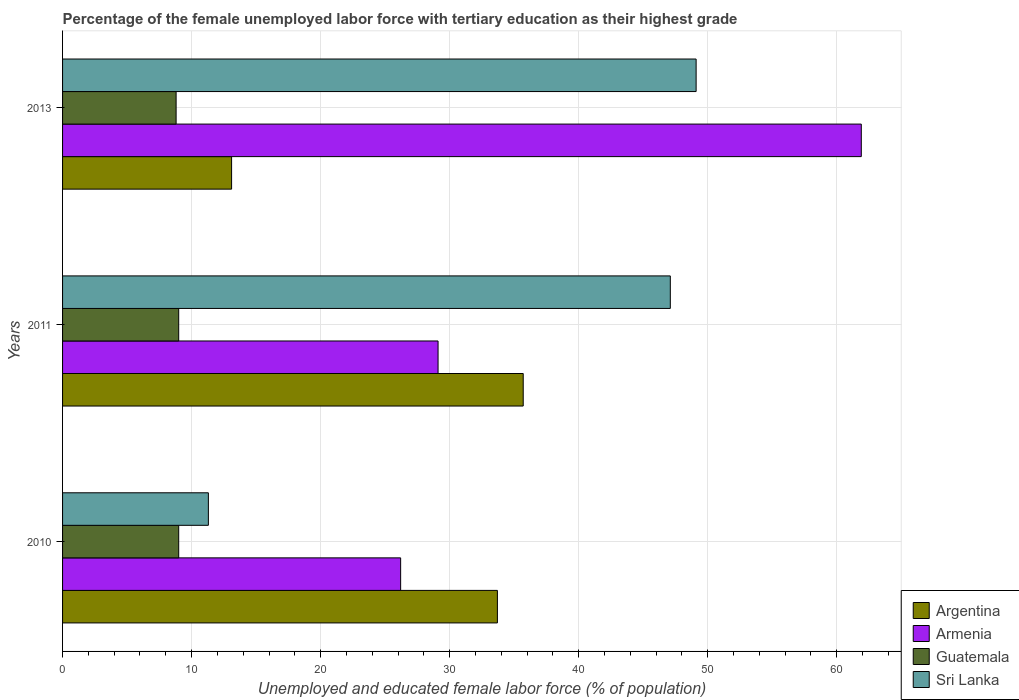How many different coloured bars are there?
Your answer should be very brief. 4. How many groups of bars are there?
Provide a short and direct response. 3. Are the number of bars per tick equal to the number of legend labels?
Ensure brevity in your answer.  Yes. Are the number of bars on each tick of the Y-axis equal?
Provide a succinct answer. Yes. What is the label of the 2nd group of bars from the top?
Give a very brief answer. 2011. What is the percentage of the unemployed female labor force with tertiary education in Guatemala in 2011?
Your answer should be compact. 9. Across all years, what is the maximum percentage of the unemployed female labor force with tertiary education in Sri Lanka?
Your response must be concise. 49.1. Across all years, what is the minimum percentage of the unemployed female labor force with tertiary education in Sri Lanka?
Make the answer very short. 11.3. In which year was the percentage of the unemployed female labor force with tertiary education in Argentina maximum?
Keep it short and to the point. 2011. What is the total percentage of the unemployed female labor force with tertiary education in Argentina in the graph?
Keep it short and to the point. 82.5. What is the difference between the percentage of the unemployed female labor force with tertiary education in Sri Lanka in 2010 and that in 2013?
Your answer should be very brief. -37.8. What is the difference between the percentage of the unemployed female labor force with tertiary education in Guatemala in 2010 and the percentage of the unemployed female labor force with tertiary education in Argentina in 2013?
Keep it short and to the point. -4.1. What is the average percentage of the unemployed female labor force with tertiary education in Armenia per year?
Your answer should be compact. 39.07. In the year 2011, what is the difference between the percentage of the unemployed female labor force with tertiary education in Guatemala and percentage of the unemployed female labor force with tertiary education in Armenia?
Keep it short and to the point. -20.1. In how many years, is the percentage of the unemployed female labor force with tertiary education in Argentina greater than 6 %?
Make the answer very short. 3. Is the percentage of the unemployed female labor force with tertiary education in Sri Lanka in 2010 less than that in 2013?
Provide a short and direct response. Yes. Is the difference between the percentage of the unemployed female labor force with tertiary education in Guatemala in 2010 and 2011 greater than the difference between the percentage of the unemployed female labor force with tertiary education in Armenia in 2010 and 2011?
Your response must be concise. Yes. What is the difference between the highest and the second highest percentage of the unemployed female labor force with tertiary education in Argentina?
Provide a short and direct response. 2. What is the difference between the highest and the lowest percentage of the unemployed female labor force with tertiary education in Guatemala?
Give a very brief answer. 0.2. What does the 3rd bar from the top in 2013 represents?
Your answer should be compact. Armenia. What does the 3rd bar from the bottom in 2011 represents?
Offer a terse response. Guatemala. How many bars are there?
Provide a succinct answer. 12. Does the graph contain grids?
Make the answer very short. Yes. How many legend labels are there?
Offer a very short reply. 4. What is the title of the graph?
Keep it short and to the point. Percentage of the female unemployed labor force with tertiary education as their highest grade. What is the label or title of the X-axis?
Offer a very short reply. Unemployed and educated female labor force (% of population). What is the Unemployed and educated female labor force (% of population) of Argentina in 2010?
Provide a short and direct response. 33.7. What is the Unemployed and educated female labor force (% of population) in Armenia in 2010?
Offer a terse response. 26.2. What is the Unemployed and educated female labor force (% of population) in Guatemala in 2010?
Your response must be concise. 9. What is the Unemployed and educated female labor force (% of population) in Sri Lanka in 2010?
Keep it short and to the point. 11.3. What is the Unemployed and educated female labor force (% of population) in Argentina in 2011?
Offer a terse response. 35.7. What is the Unemployed and educated female labor force (% of population) of Armenia in 2011?
Offer a very short reply. 29.1. What is the Unemployed and educated female labor force (% of population) in Guatemala in 2011?
Give a very brief answer. 9. What is the Unemployed and educated female labor force (% of population) in Sri Lanka in 2011?
Ensure brevity in your answer.  47.1. What is the Unemployed and educated female labor force (% of population) in Argentina in 2013?
Offer a very short reply. 13.1. What is the Unemployed and educated female labor force (% of population) of Armenia in 2013?
Keep it short and to the point. 61.9. What is the Unemployed and educated female labor force (% of population) of Guatemala in 2013?
Provide a succinct answer. 8.8. What is the Unemployed and educated female labor force (% of population) of Sri Lanka in 2013?
Give a very brief answer. 49.1. Across all years, what is the maximum Unemployed and educated female labor force (% of population) in Argentina?
Make the answer very short. 35.7. Across all years, what is the maximum Unemployed and educated female labor force (% of population) in Armenia?
Offer a very short reply. 61.9. Across all years, what is the maximum Unemployed and educated female labor force (% of population) in Guatemala?
Provide a succinct answer. 9. Across all years, what is the maximum Unemployed and educated female labor force (% of population) of Sri Lanka?
Your response must be concise. 49.1. Across all years, what is the minimum Unemployed and educated female labor force (% of population) in Argentina?
Provide a succinct answer. 13.1. Across all years, what is the minimum Unemployed and educated female labor force (% of population) of Armenia?
Give a very brief answer. 26.2. Across all years, what is the minimum Unemployed and educated female labor force (% of population) in Guatemala?
Provide a short and direct response. 8.8. Across all years, what is the minimum Unemployed and educated female labor force (% of population) in Sri Lanka?
Your response must be concise. 11.3. What is the total Unemployed and educated female labor force (% of population) of Argentina in the graph?
Offer a terse response. 82.5. What is the total Unemployed and educated female labor force (% of population) of Armenia in the graph?
Your response must be concise. 117.2. What is the total Unemployed and educated female labor force (% of population) of Guatemala in the graph?
Your answer should be very brief. 26.8. What is the total Unemployed and educated female labor force (% of population) of Sri Lanka in the graph?
Ensure brevity in your answer.  107.5. What is the difference between the Unemployed and educated female labor force (% of population) of Argentina in 2010 and that in 2011?
Ensure brevity in your answer.  -2. What is the difference between the Unemployed and educated female labor force (% of population) of Armenia in 2010 and that in 2011?
Your answer should be compact. -2.9. What is the difference between the Unemployed and educated female labor force (% of population) of Guatemala in 2010 and that in 2011?
Ensure brevity in your answer.  0. What is the difference between the Unemployed and educated female labor force (% of population) of Sri Lanka in 2010 and that in 2011?
Your answer should be very brief. -35.8. What is the difference between the Unemployed and educated female labor force (% of population) of Argentina in 2010 and that in 2013?
Give a very brief answer. 20.6. What is the difference between the Unemployed and educated female labor force (% of population) in Armenia in 2010 and that in 2013?
Keep it short and to the point. -35.7. What is the difference between the Unemployed and educated female labor force (% of population) in Sri Lanka in 2010 and that in 2013?
Ensure brevity in your answer.  -37.8. What is the difference between the Unemployed and educated female labor force (% of population) in Argentina in 2011 and that in 2013?
Ensure brevity in your answer.  22.6. What is the difference between the Unemployed and educated female labor force (% of population) in Armenia in 2011 and that in 2013?
Offer a very short reply. -32.8. What is the difference between the Unemployed and educated female labor force (% of population) of Argentina in 2010 and the Unemployed and educated female labor force (% of population) of Armenia in 2011?
Your answer should be compact. 4.6. What is the difference between the Unemployed and educated female labor force (% of population) of Argentina in 2010 and the Unemployed and educated female labor force (% of population) of Guatemala in 2011?
Your response must be concise. 24.7. What is the difference between the Unemployed and educated female labor force (% of population) of Argentina in 2010 and the Unemployed and educated female labor force (% of population) of Sri Lanka in 2011?
Make the answer very short. -13.4. What is the difference between the Unemployed and educated female labor force (% of population) in Armenia in 2010 and the Unemployed and educated female labor force (% of population) in Guatemala in 2011?
Your answer should be compact. 17.2. What is the difference between the Unemployed and educated female labor force (% of population) in Armenia in 2010 and the Unemployed and educated female labor force (% of population) in Sri Lanka in 2011?
Provide a short and direct response. -20.9. What is the difference between the Unemployed and educated female labor force (% of population) of Guatemala in 2010 and the Unemployed and educated female labor force (% of population) of Sri Lanka in 2011?
Offer a terse response. -38.1. What is the difference between the Unemployed and educated female labor force (% of population) in Argentina in 2010 and the Unemployed and educated female labor force (% of population) in Armenia in 2013?
Give a very brief answer. -28.2. What is the difference between the Unemployed and educated female labor force (% of population) of Argentina in 2010 and the Unemployed and educated female labor force (% of population) of Guatemala in 2013?
Offer a terse response. 24.9. What is the difference between the Unemployed and educated female labor force (% of population) of Argentina in 2010 and the Unemployed and educated female labor force (% of population) of Sri Lanka in 2013?
Your answer should be very brief. -15.4. What is the difference between the Unemployed and educated female labor force (% of population) in Armenia in 2010 and the Unemployed and educated female labor force (% of population) in Sri Lanka in 2013?
Keep it short and to the point. -22.9. What is the difference between the Unemployed and educated female labor force (% of population) of Guatemala in 2010 and the Unemployed and educated female labor force (% of population) of Sri Lanka in 2013?
Provide a succinct answer. -40.1. What is the difference between the Unemployed and educated female labor force (% of population) in Argentina in 2011 and the Unemployed and educated female labor force (% of population) in Armenia in 2013?
Your answer should be very brief. -26.2. What is the difference between the Unemployed and educated female labor force (% of population) in Argentina in 2011 and the Unemployed and educated female labor force (% of population) in Guatemala in 2013?
Your answer should be very brief. 26.9. What is the difference between the Unemployed and educated female labor force (% of population) in Argentina in 2011 and the Unemployed and educated female labor force (% of population) in Sri Lanka in 2013?
Your answer should be compact. -13.4. What is the difference between the Unemployed and educated female labor force (% of population) of Armenia in 2011 and the Unemployed and educated female labor force (% of population) of Guatemala in 2013?
Keep it short and to the point. 20.3. What is the difference between the Unemployed and educated female labor force (% of population) in Guatemala in 2011 and the Unemployed and educated female labor force (% of population) in Sri Lanka in 2013?
Give a very brief answer. -40.1. What is the average Unemployed and educated female labor force (% of population) of Armenia per year?
Your response must be concise. 39.07. What is the average Unemployed and educated female labor force (% of population) of Guatemala per year?
Keep it short and to the point. 8.93. What is the average Unemployed and educated female labor force (% of population) in Sri Lanka per year?
Offer a very short reply. 35.83. In the year 2010, what is the difference between the Unemployed and educated female labor force (% of population) of Argentina and Unemployed and educated female labor force (% of population) of Armenia?
Your answer should be compact. 7.5. In the year 2010, what is the difference between the Unemployed and educated female labor force (% of population) in Argentina and Unemployed and educated female labor force (% of population) in Guatemala?
Offer a terse response. 24.7. In the year 2010, what is the difference between the Unemployed and educated female labor force (% of population) of Argentina and Unemployed and educated female labor force (% of population) of Sri Lanka?
Offer a very short reply. 22.4. In the year 2010, what is the difference between the Unemployed and educated female labor force (% of population) of Armenia and Unemployed and educated female labor force (% of population) of Guatemala?
Make the answer very short. 17.2. In the year 2011, what is the difference between the Unemployed and educated female labor force (% of population) of Argentina and Unemployed and educated female labor force (% of population) of Armenia?
Provide a succinct answer. 6.6. In the year 2011, what is the difference between the Unemployed and educated female labor force (% of population) of Argentina and Unemployed and educated female labor force (% of population) of Guatemala?
Ensure brevity in your answer.  26.7. In the year 2011, what is the difference between the Unemployed and educated female labor force (% of population) of Armenia and Unemployed and educated female labor force (% of population) of Guatemala?
Offer a terse response. 20.1. In the year 2011, what is the difference between the Unemployed and educated female labor force (% of population) of Armenia and Unemployed and educated female labor force (% of population) of Sri Lanka?
Give a very brief answer. -18. In the year 2011, what is the difference between the Unemployed and educated female labor force (% of population) of Guatemala and Unemployed and educated female labor force (% of population) of Sri Lanka?
Provide a succinct answer. -38.1. In the year 2013, what is the difference between the Unemployed and educated female labor force (% of population) of Argentina and Unemployed and educated female labor force (% of population) of Armenia?
Ensure brevity in your answer.  -48.8. In the year 2013, what is the difference between the Unemployed and educated female labor force (% of population) in Argentina and Unemployed and educated female labor force (% of population) in Sri Lanka?
Make the answer very short. -36. In the year 2013, what is the difference between the Unemployed and educated female labor force (% of population) of Armenia and Unemployed and educated female labor force (% of population) of Guatemala?
Ensure brevity in your answer.  53.1. In the year 2013, what is the difference between the Unemployed and educated female labor force (% of population) in Guatemala and Unemployed and educated female labor force (% of population) in Sri Lanka?
Make the answer very short. -40.3. What is the ratio of the Unemployed and educated female labor force (% of population) in Argentina in 2010 to that in 2011?
Give a very brief answer. 0.94. What is the ratio of the Unemployed and educated female labor force (% of population) in Armenia in 2010 to that in 2011?
Keep it short and to the point. 0.9. What is the ratio of the Unemployed and educated female labor force (% of population) in Guatemala in 2010 to that in 2011?
Provide a succinct answer. 1. What is the ratio of the Unemployed and educated female labor force (% of population) in Sri Lanka in 2010 to that in 2011?
Provide a succinct answer. 0.24. What is the ratio of the Unemployed and educated female labor force (% of population) in Argentina in 2010 to that in 2013?
Your response must be concise. 2.57. What is the ratio of the Unemployed and educated female labor force (% of population) of Armenia in 2010 to that in 2013?
Provide a succinct answer. 0.42. What is the ratio of the Unemployed and educated female labor force (% of population) in Guatemala in 2010 to that in 2013?
Your answer should be compact. 1.02. What is the ratio of the Unemployed and educated female labor force (% of population) in Sri Lanka in 2010 to that in 2013?
Give a very brief answer. 0.23. What is the ratio of the Unemployed and educated female labor force (% of population) in Argentina in 2011 to that in 2013?
Offer a very short reply. 2.73. What is the ratio of the Unemployed and educated female labor force (% of population) of Armenia in 2011 to that in 2013?
Provide a succinct answer. 0.47. What is the ratio of the Unemployed and educated female labor force (% of population) in Guatemala in 2011 to that in 2013?
Keep it short and to the point. 1.02. What is the ratio of the Unemployed and educated female labor force (% of population) in Sri Lanka in 2011 to that in 2013?
Give a very brief answer. 0.96. What is the difference between the highest and the second highest Unemployed and educated female labor force (% of population) of Armenia?
Make the answer very short. 32.8. What is the difference between the highest and the lowest Unemployed and educated female labor force (% of population) in Argentina?
Offer a terse response. 22.6. What is the difference between the highest and the lowest Unemployed and educated female labor force (% of population) of Armenia?
Keep it short and to the point. 35.7. What is the difference between the highest and the lowest Unemployed and educated female labor force (% of population) in Guatemala?
Your answer should be very brief. 0.2. What is the difference between the highest and the lowest Unemployed and educated female labor force (% of population) of Sri Lanka?
Offer a terse response. 37.8. 